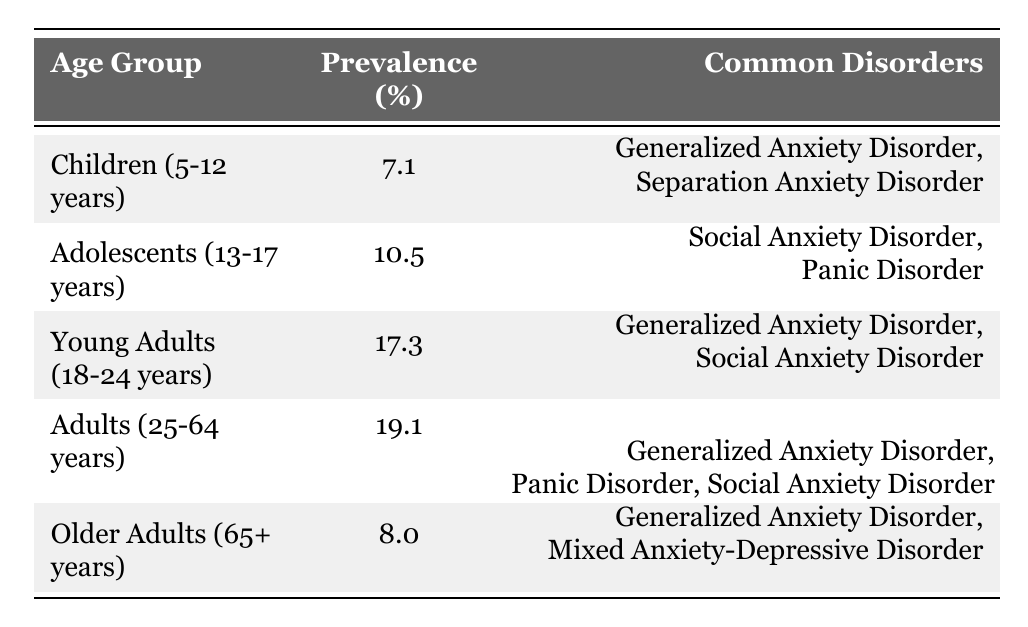What is the prevalence of anxiety disorders in adolescents? The table shows that the prevalence percentage for adolescents (ages 13-17 years) is 10.5%.
Answer: 10.5% Which age group has the highest prevalence of anxiety disorders? According to the table, the age group with the highest prevalence is Adults (25-64 years) at 19.1%.
Answer: Adults (25-64 years) What are the common anxiety disorders among young adults? The table lists the common disorders for young adults (aged 18-24 years) as Generalized Anxiety Disorder and Social Anxiety Disorder.
Answer: Generalized Anxiety Disorder, Social Anxiety Disorder Is the prevalence of anxiety disorders higher in older adults compared to children? The table shows that older adults (65+ years) have a prevalence of 8.0%, while children (5-12 years) have a prevalence of 7.1%. Since 8.0% is greater than 7.1%, the statement is true.
Answer: Yes What is the average prevalence of anxiety disorders across all age groups? To find the average, sum the prevalence percentages: (7.1 + 10.5 + 17.3 + 19.1 + 8.0) = 62.0. Then divide by the number of age groups (5): 62.0 / 5 = 12.4%.
Answer: 12.4% Which common disorder appears in both children and older adults? The table indicates that Generalized Anxiety Disorder is listed as a common disorder for both children (5-12 years) and older adults (65+ years).
Answer: Generalized Anxiety Disorder How much higher is the prevalence of anxiety disorders in young adults compared to children? The prevalence for young adults is 17.3% and for children is 7.1%. The difference is calculated as 17.3% - 7.1% = 10.2%.
Answer: 10.2% Are there any common anxiety disorders among adults that are not listed for other age groups? The common disorders for adults (25-64 years) include Panic Disorder and Social Anxiety Disorder; Panic Disorder does not appear in other age groups. Therefore, the statement is true.
Answer: Yes What percentage of young adults experience Social Anxiety Disorder? The table indicates that Social Anxiety Disorder is listed among common disorders for young adults, but does not provide specific prevalence for this disorder alone. Thus, the exact percentage cannot be determined.
Answer: Not specified 